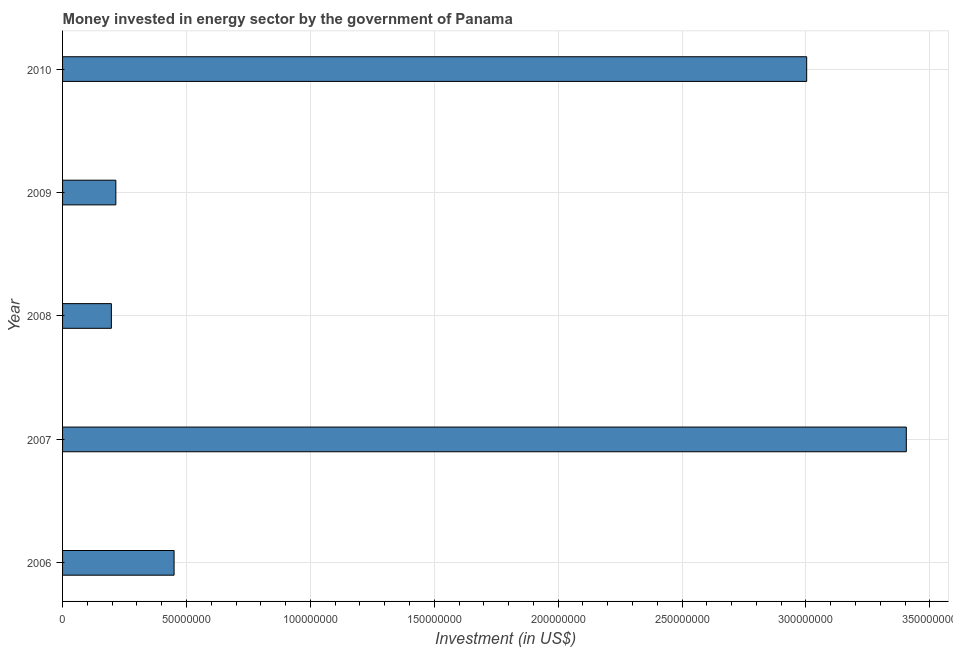Does the graph contain any zero values?
Offer a very short reply. No. What is the title of the graph?
Provide a short and direct response. Money invested in energy sector by the government of Panama. What is the label or title of the X-axis?
Make the answer very short. Investment (in US$). What is the investment in energy in 2008?
Offer a terse response. 1.97e+07. Across all years, what is the maximum investment in energy?
Your response must be concise. 3.40e+08. Across all years, what is the minimum investment in energy?
Your response must be concise. 1.97e+07. What is the sum of the investment in energy?
Offer a very short reply. 7.27e+08. What is the difference between the investment in energy in 2006 and 2008?
Provide a succinct answer. 2.53e+07. What is the average investment in energy per year?
Offer a terse response. 1.45e+08. What is the median investment in energy?
Offer a very short reply. 4.50e+07. In how many years, is the investment in energy greater than 320000000 US$?
Keep it short and to the point. 1. What is the ratio of the investment in energy in 2006 to that in 2007?
Keep it short and to the point. 0.13. What is the difference between the highest and the second highest investment in energy?
Offer a terse response. 4.02e+07. Is the sum of the investment in energy in 2006 and 2009 greater than the maximum investment in energy across all years?
Offer a very short reply. No. What is the difference between the highest and the lowest investment in energy?
Provide a short and direct response. 3.21e+08. How many bars are there?
Keep it short and to the point. 5. Are all the bars in the graph horizontal?
Offer a terse response. Yes. What is the difference between two consecutive major ticks on the X-axis?
Offer a very short reply. 5.00e+07. Are the values on the major ticks of X-axis written in scientific E-notation?
Your answer should be very brief. No. What is the Investment (in US$) in 2006?
Your answer should be compact. 4.50e+07. What is the Investment (in US$) in 2007?
Your answer should be very brief. 3.40e+08. What is the Investment (in US$) in 2008?
Provide a short and direct response. 1.97e+07. What is the Investment (in US$) in 2009?
Keep it short and to the point. 2.15e+07. What is the Investment (in US$) of 2010?
Ensure brevity in your answer.  3.00e+08. What is the difference between the Investment (in US$) in 2006 and 2007?
Give a very brief answer. -2.96e+08. What is the difference between the Investment (in US$) in 2006 and 2008?
Give a very brief answer. 2.53e+07. What is the difference between the Investment (in US$) in 2006 and 2009?
Ensure brevity in your answer.  2.35e+07. What is the difference between the Investment (in US$) in 2006 and 2010?
Keep it short and to the point. -2.55e+08. What is the difference between the Investment (in US$) in 2007 and 2008?
Provide a succinct answer. 3.21e+08. What is the difference between the Investment (in US$) in 2007 and 2009?
Provide a short and direct response. 3.19e+08. What is the difference between the Investment (in US$) in 2007 and 2010?
Keep it short and to the point. 4.02e+07. What is the difference between the Investment (in US$) in 2008 and 2009?
Your answer should be very brief. -1.80e+06. What is the difference between the Investment (in US$) in 2008 and 2010?
Offer a terse response. -2.81e+08. What is the difference between the Investment (in US$) in 2009 and 2010?
Your answer should be compact. -2.79e+08. What is the ratio of the Investment (in US$) in 2006 to that in 2007?
Make the answer very short. 0.13. What is the ratio of the Investment (in US$) in 2006 to that in 2008?
Provide a succinct answer. 2.28. What is the ratio of the Investment (in US$) in 2006 to that in 2009?
Give a very brief answer. 2.09. What is the ratio of the Investment (in US$) in 2006 to that in 2010?
Ensure brevity in your answer.  0.15. What is the ratio of the Investment (in US$) in 2007 to that in 2008?
Your answer should be compact. 17.28. What is the ratio of the Investment (in US$) in 2007 to that in 2009?
Your answer should be very brief. 15.84. What is the ratio of the Investment (in US$) in 2007 to that in 2010?
Your response must be concise. 1.13. What is the ratio of the Investment (in US$) in 2008 to that in 2009?
Ensure brevity in your answer.  0.92. What is the ratio of the Investment (in US$) in 2008 to that in 2010?
Ensure brevity in your answer.  0.07. What is the ratio of the Investment (in US$) in 2009 to that in 2010?
Ensure brevity in your answer.  0.07. 